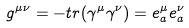Convert formula to latex. <formula><loc_0><loc_0><loc_500><loc_500>g ^ { \mu \nu } = - t r ( \gamma ^ { \mu } \gamma ^ { \nu } ) = e ^ { \mu } _ { a } e ^ { \nu } _ { a }</formula> 